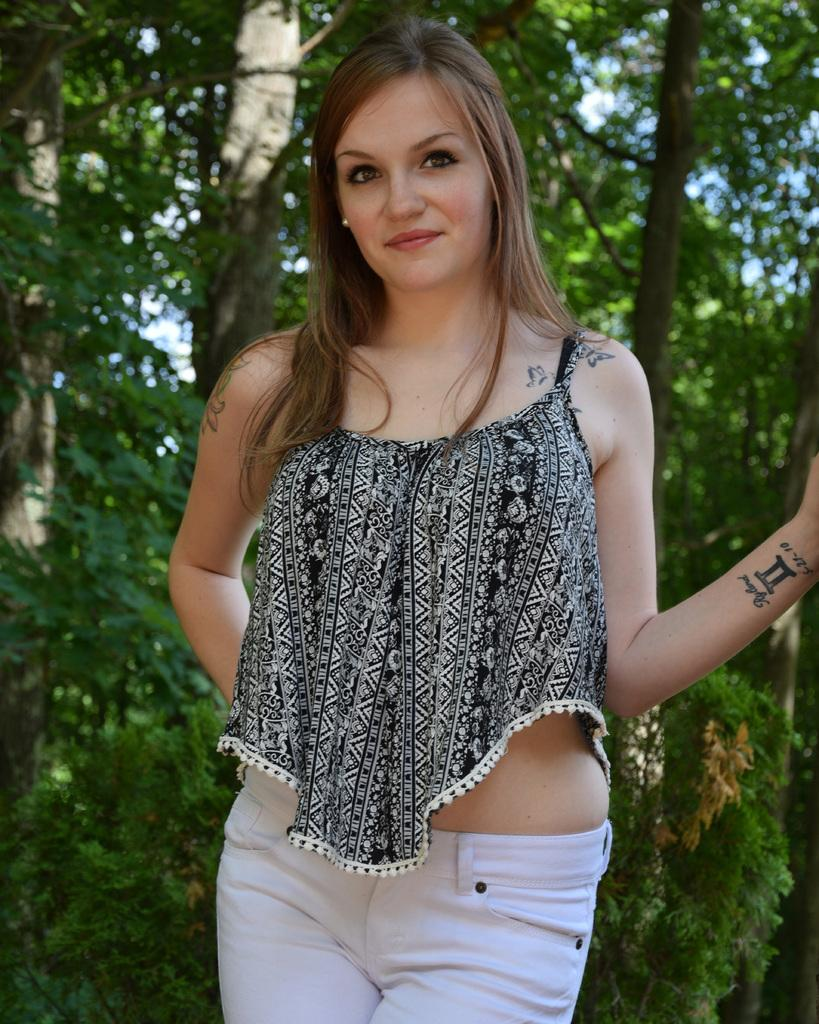Who is present in the image? There is a woman in the image. What is the woman doing in the image? The woman is standing and posing for a photo. What can be seen in the background of the image? There are trees behind the woman in the image. What type of doll is the woman holding in the image? There is no doll present in the image; the woman is posing for a photo with no visible objects in her hands. 